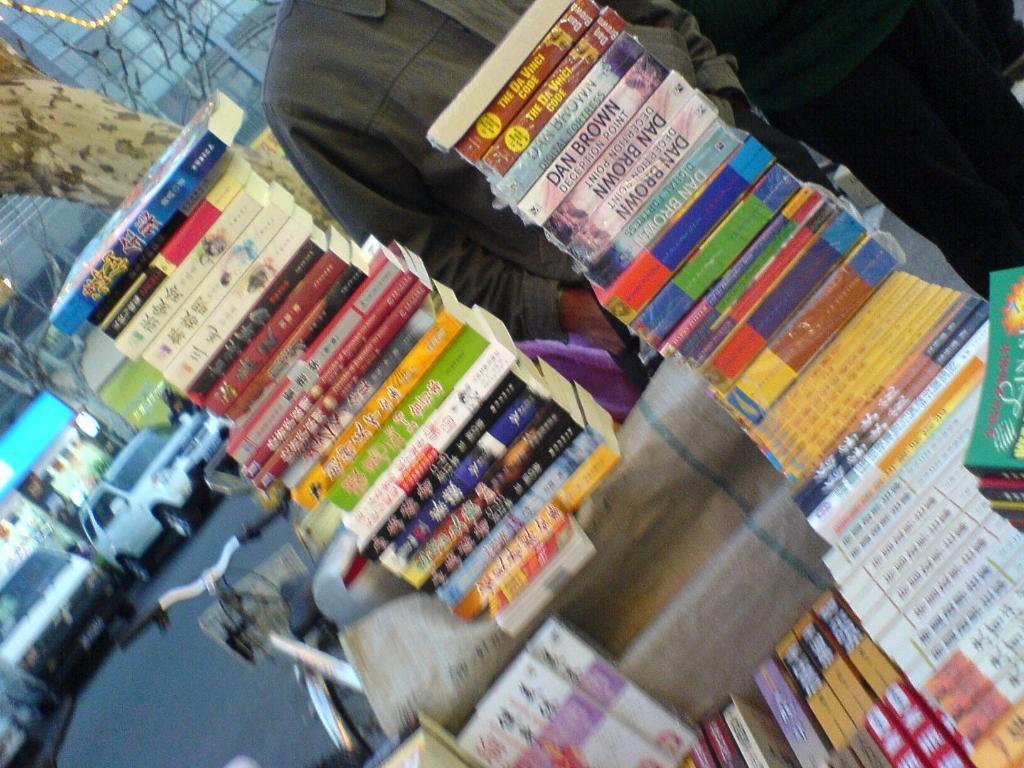<image>
Relay a brief, clear account of the picture shown. A stack of Dan Brown books of various titles in an outdoor display. 